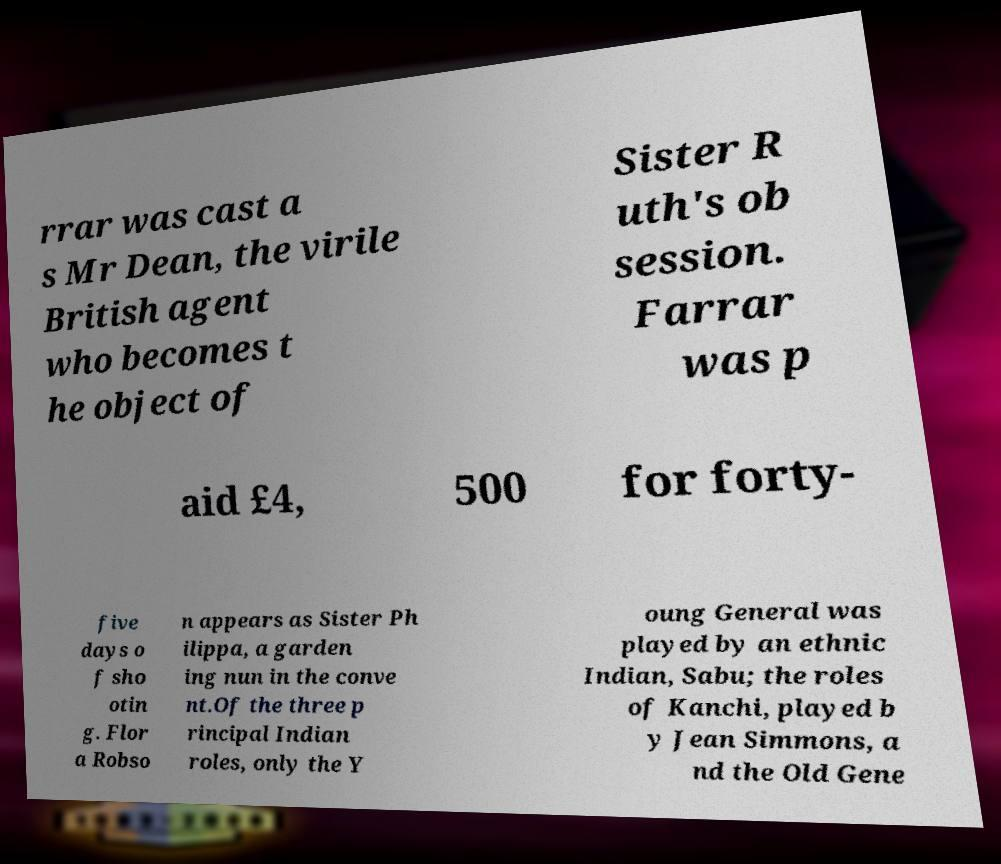For documentation purposes, I need the text within this image transcribed. Could you provide that? rrar was cast a s Mr Dean, the virile British agent who becomes t he object of Sister R uth's ob session. Farrar was p aid £4, 500 for forty- five days o f sho otin g. Flor a Robso n appears as Sister Ph ilippa, a garden ing nun in the conve nt.Of the three p rincipal Indian roles, only the Y oung General was played by an ethnic Indian, Sabu; the roles of Kanchi, played b y Jean Simmons, a nd the Old Gene 